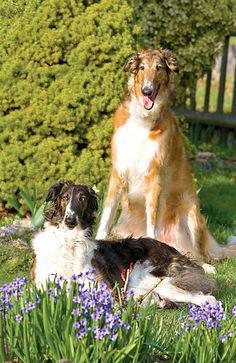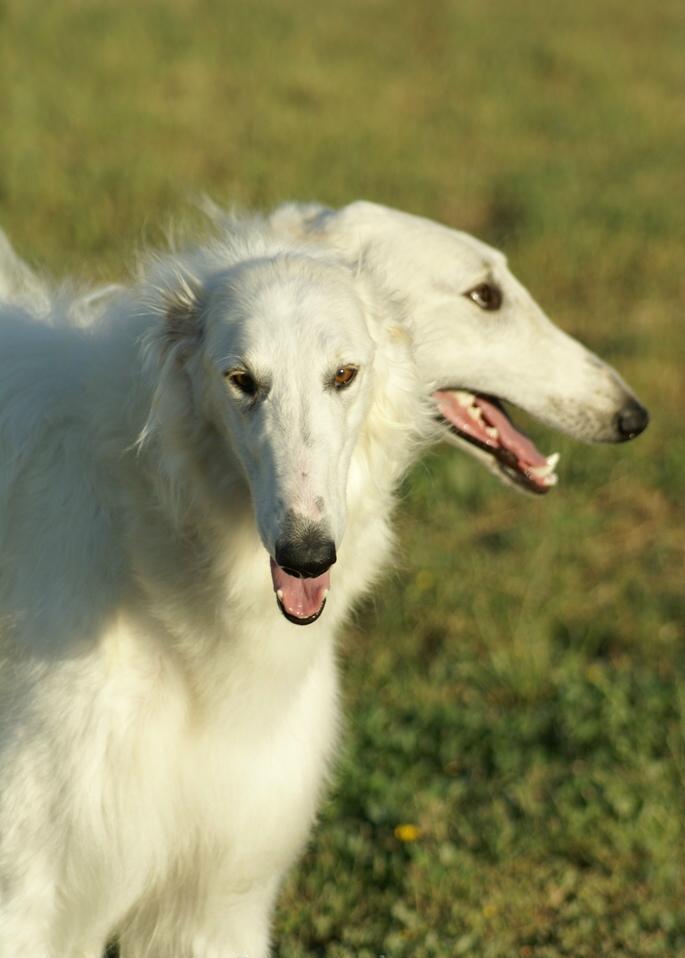The first image is the image on the left, the second image is the image on the right. Examine the images to the left and right. Is the description "Each image shows exactly two furry hounds posed next to each other outdoors on grass." accurate? Answer yes or no. Yes. The first image is the image on the left, the second image is the image on the right. Assess this claim about the two images: "There are two dogs in each image.". Correct or not? Answer yes or no. Yes. 